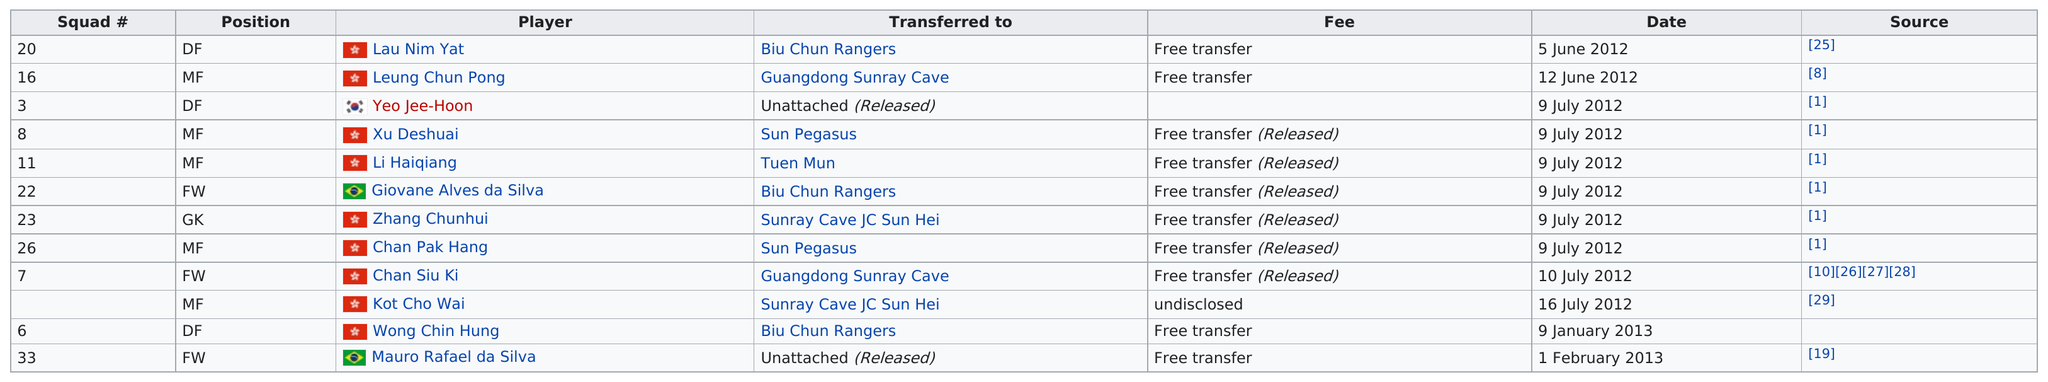List a handful of essential elements in this visual. In total, 2 players were transferred to Sun Pegasus. I'm sorry, but it is not clear what you are asking. Could you please provide more context or clarify your question? The previous squad number before squad number 7 is 26. On January 9th, 2013, Wong Chin Hung was transferred to his new team. The first player has transferred out to Sunray Cave JC Sun Hei. Zhang Chunhui is the recipient of this transfer. 